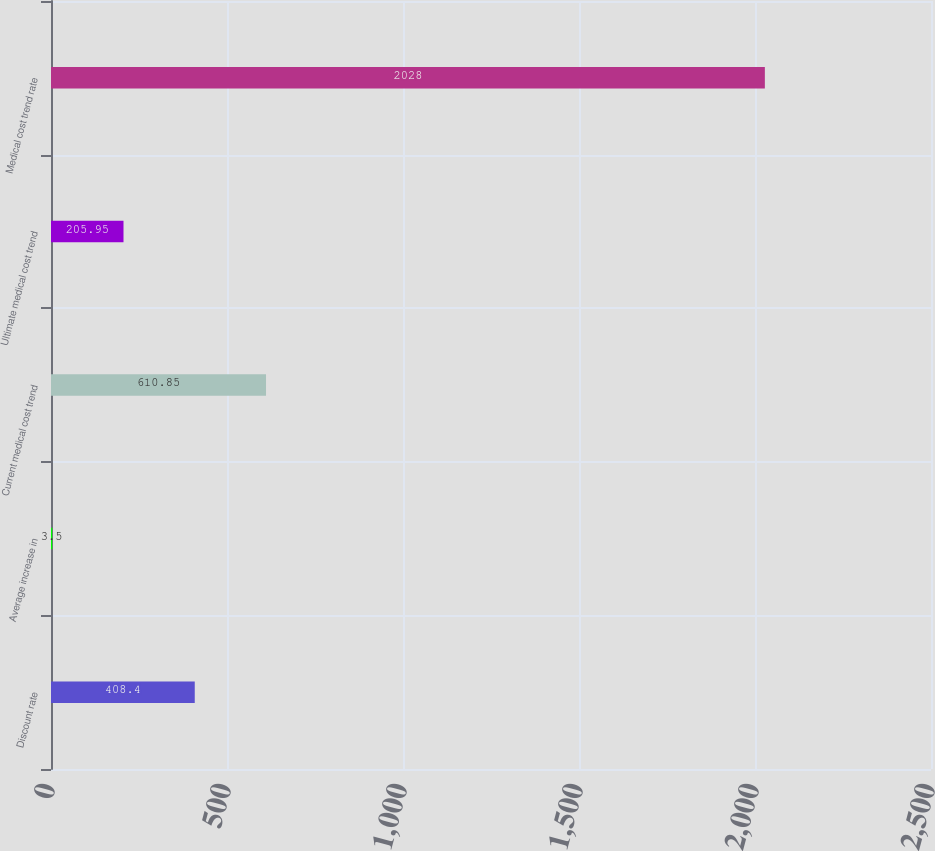Convert chart. <chart><loc_0><loc_0><loc_500><loc_500><bar_chart><fcel>Discount rate<fcel>Average increase in<fcel>Current medical cost trend<fcel>Ultimate medical cost trend<fcel>Medical cost trend rate<nl><fcel>408.4<fcel>3.5<fcel>610.85<fcel>205.95<fcel>2028<nl></chart> 